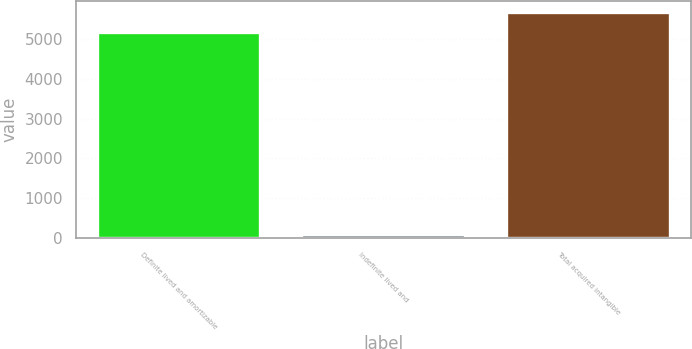<chart> <loc_0><loc_0><loc_500><loc_500><bar_chart><fcel>Definite lived and amortizable<fcel>Indefinite lived and<fcel>Total acquired intangible<nl><fcel>5166<fcel>100<fcel>5682.6<nl></chart> 